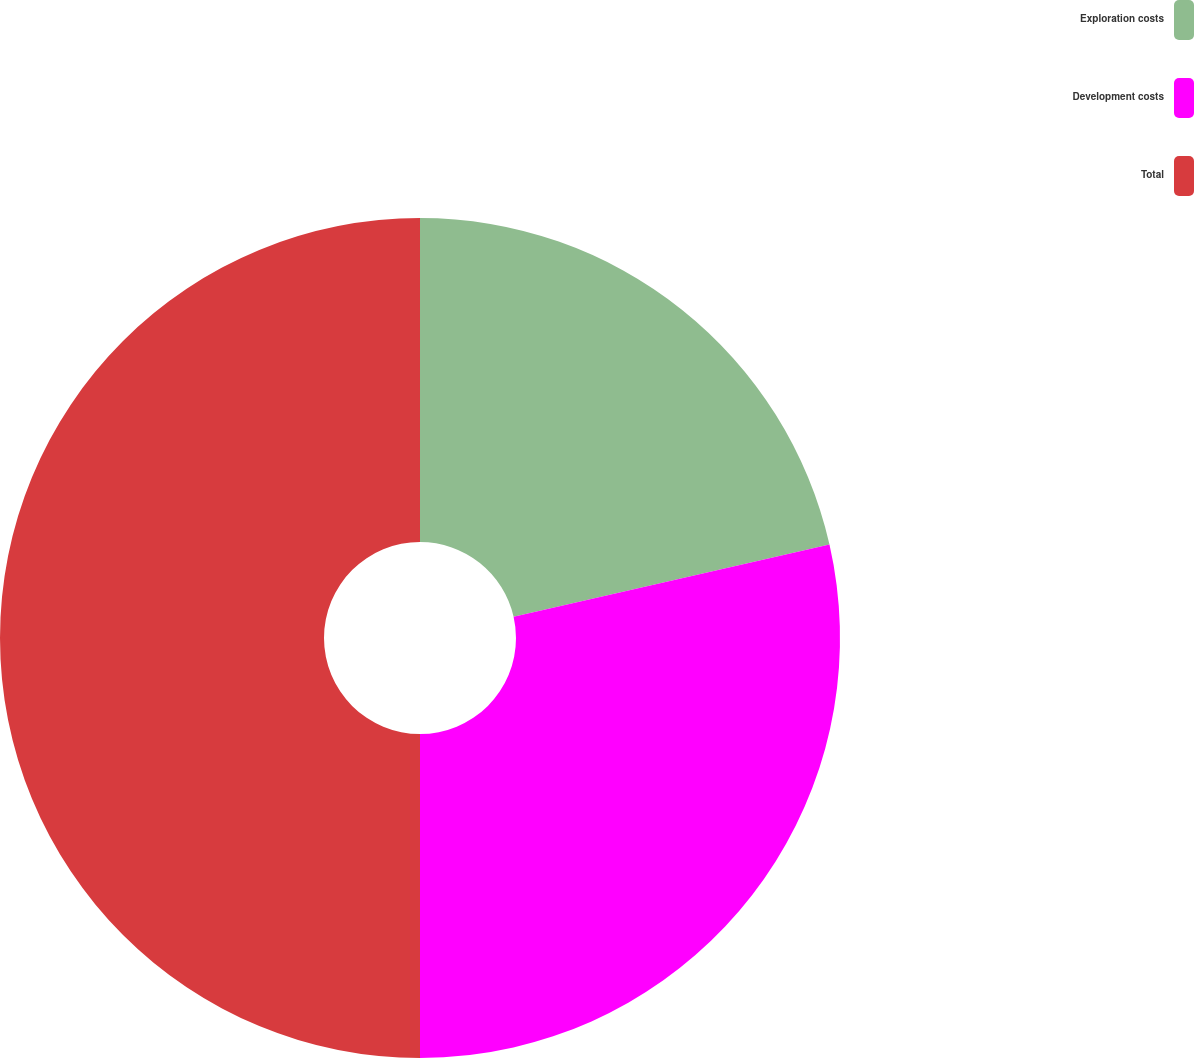Convert chart. <chart><loc_0><loc_0><loc_500><loc_500><pie_chart><fcel>Exploration costs<fcel>Development costs<fcel>Total<nl><fcel>21.43%<fcel>28.57%<fcel>50.0%<nl></chart> 